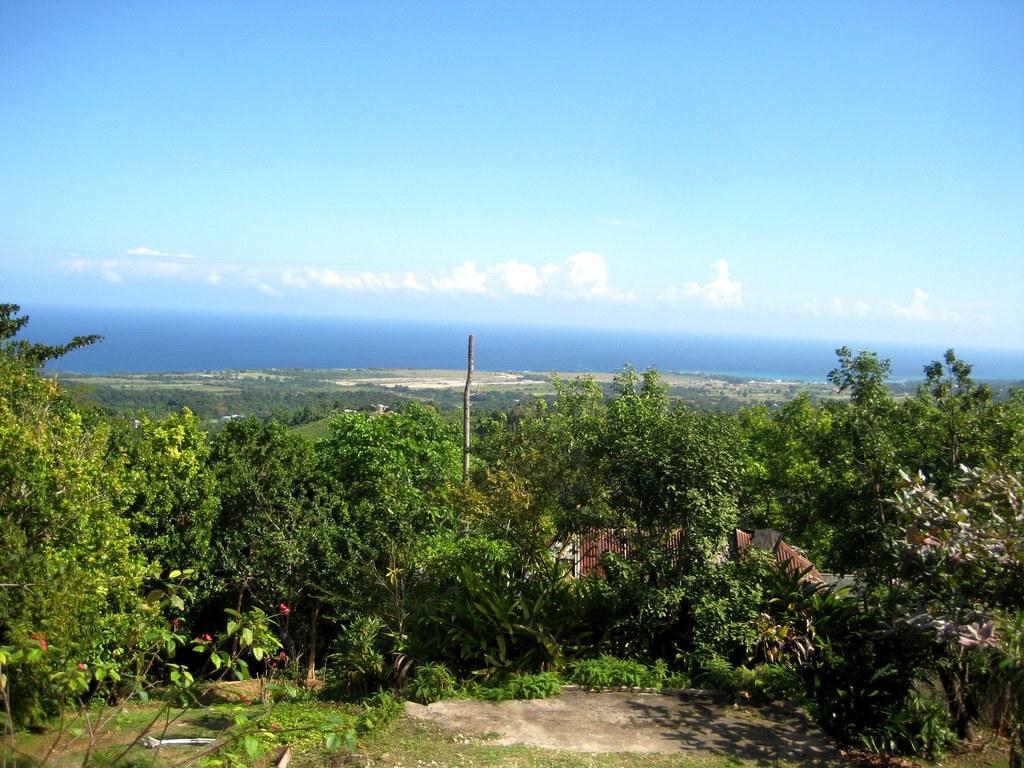Please provide a concise description of this image. In this image, we can see some trees and plants. There are clouds in the sky. There is a ocean in the middle of the image. 